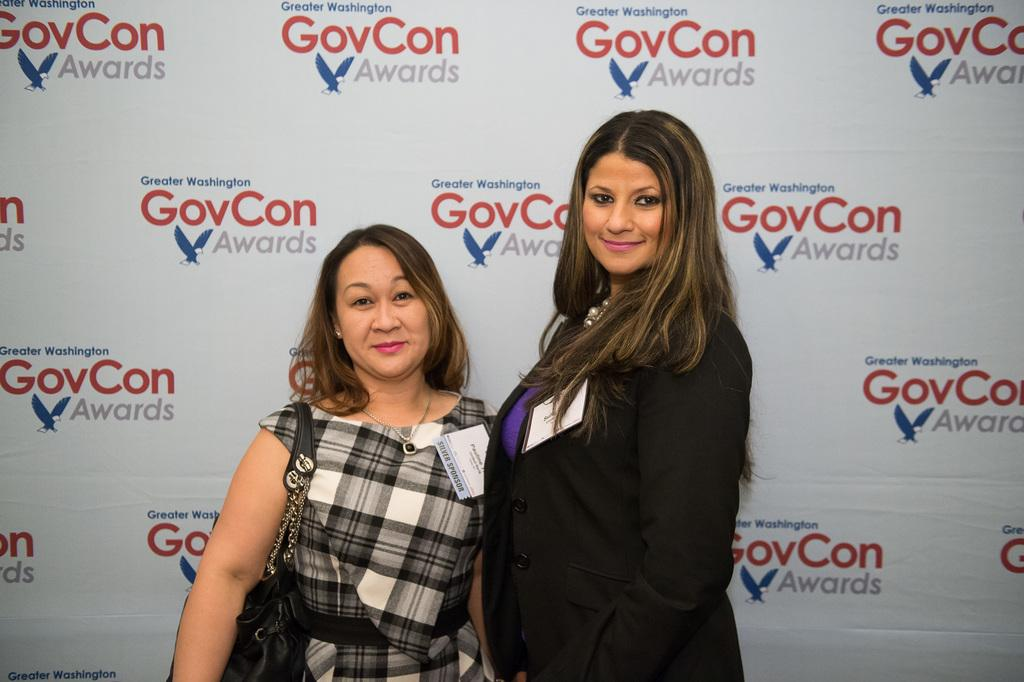How many people are in the image? There are two people in the foreground of the image. What can be seen in the background of the image? There is a poster with some text in the background of the image. What type of tent is set up in the image? There is no tent present in the image. What role does the minister play in the image? There is no minister present in the image. 